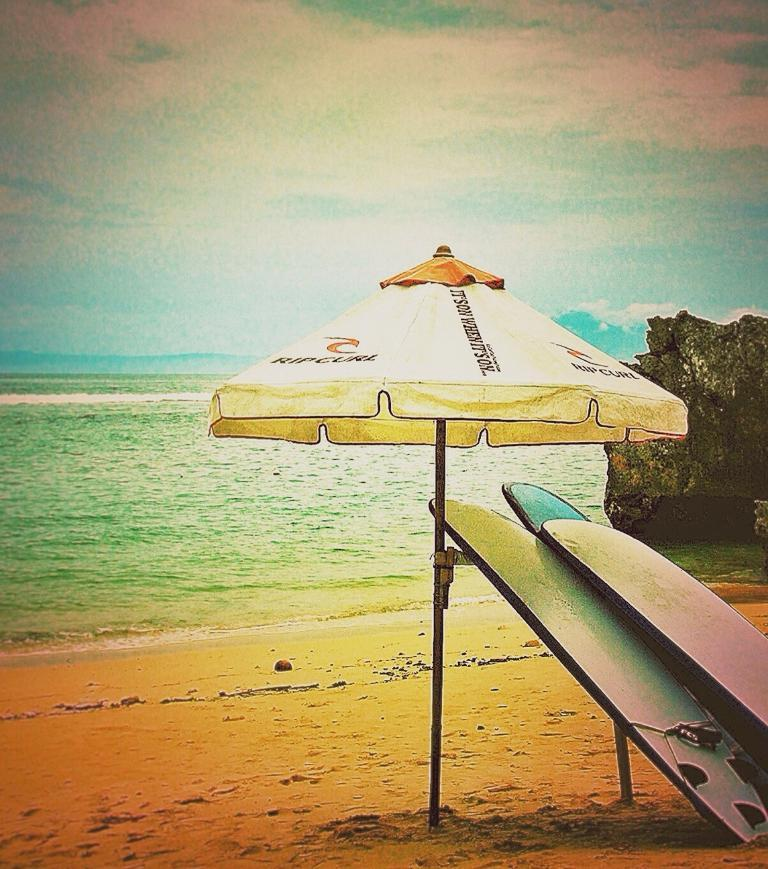What object is present in the image to provide shade or protection from the elements? There is an umbrella in the image. What type of recreational activity might be associated with the objects in the image? Surfboards are present in the image, which suggests surfing or a beach-related activity. What type of terrain is visible in the image? There is sand in the image, which suggests a beach or coastal area. What natural feature is visible in the image? There is water in the image, which could be a body of water such as an ocean or sea. What type of geological formation is visible in the image? There is a rock in the image, which could be a part of a coastal cliff or a standalone rock. What is visible in the sky in the image? The sky is visible in the image. Where is the desk located in the image? There is no desk present in the image. What decision is being made by the person in the image? There is no person present in the image, and therefore no decision-making process can be observed. 